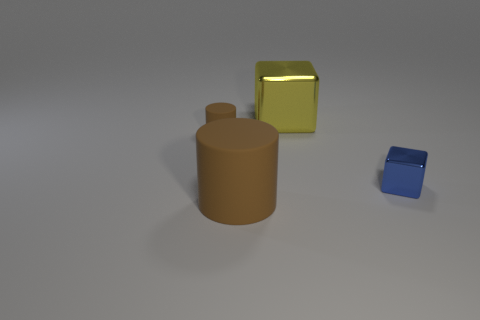Add 2 small blue things. How many objects exist? 6 Subtract all blue blocks. Subtract all brown spheres. How many blocks are left? 1 Subtract all small blue matte things. Subtract all small brown objects. How many objects are left? 3 Add 3 tiny rubber cylinders. How many tiny rubber cylinders are left? 4 Add 2 large cubes. How many large cubes exist? 3 Subtract 2 brown cylinders. How many objects are left? 2 